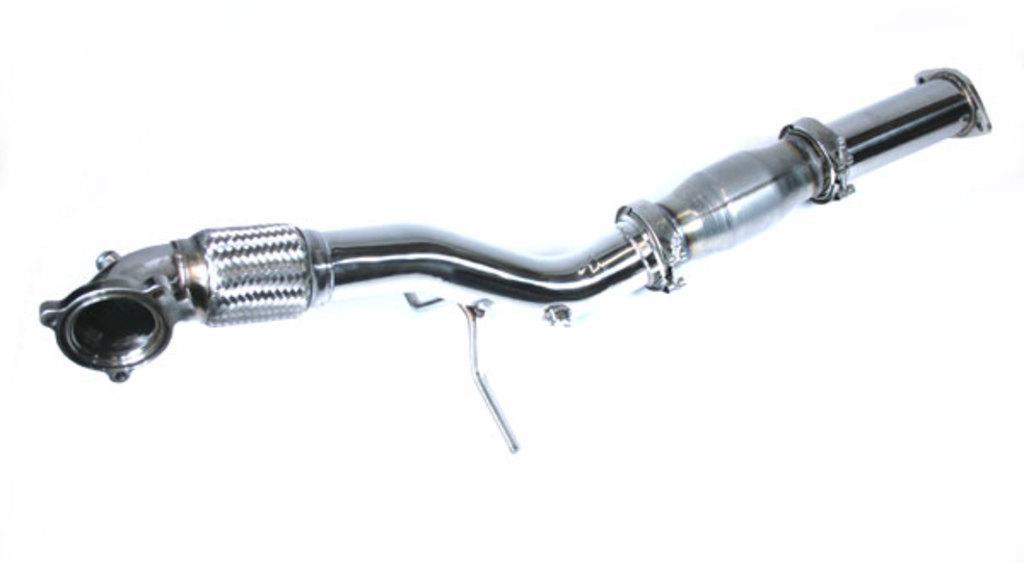How would you summarize this image in a sentence or two? In this image we can see a steel pipe. In the background it is white. 